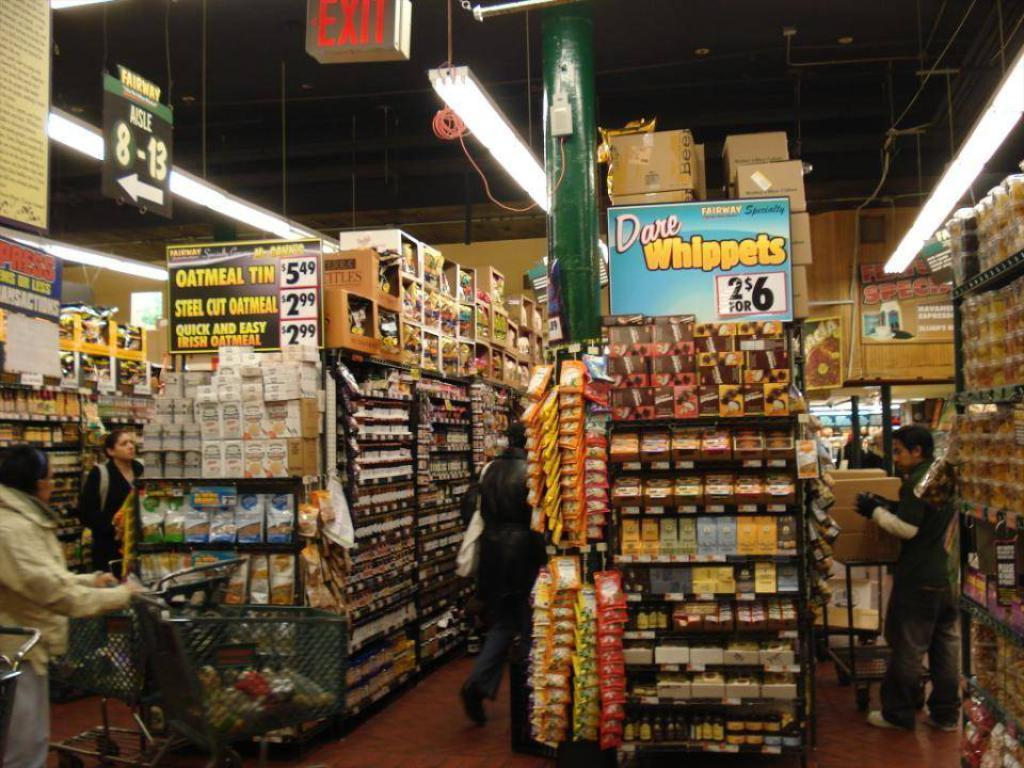<image>
Give a short and clear explanation of the subsequent image. An end cap of an aisle has a sign that says Dare Whippets. 